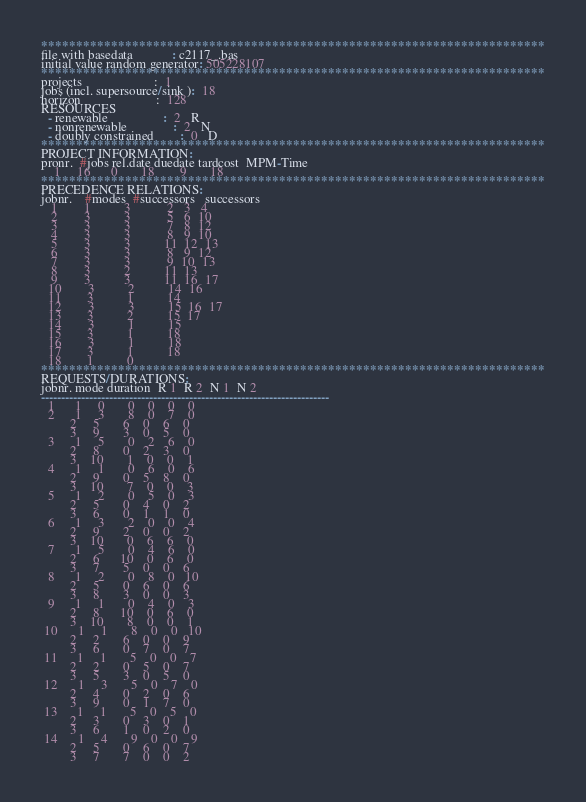<code> <loc_0><loc_0><loc_500><loc_500><_ObjectiveC_>************************************************************************
file with basedata            : c2117_.bas
initial value random generator: 505228107
************************************************************************
projects                      :  1
jobs (incl. supersource/sink ):  18
horizon                       :  128
RESOURCES
  - renewable                 :  2   R
  - nonrenewable              :  2   N
  - doubly constrained        :  0   D
************************************************************************
PROJECT INFORMATION:
pronr.  #jobs rel.date duedate tardcost  MPM-Time
    1     16      0       18        9       18
************************************************************************
PRECEDENCE RELATIONS:
jobnr.    #modes  #successors   successors
   1        1          3           2   3   4
   2        3          3           5   6  10
   3        3          3           7   8  12
   4        3          3           8   9  10
   5        3          3          11  12  13
   6        3          3           8   9  12
   7        3          3           9  10  13
   8        3          2          11  13
   9        3          3          11  16  17
  10        3          2          14  16
  11        3          1          14
  12        3          3          15  16  17
  13        3          2          15  17
  14        3          1          15
  15        3          1          18
  16        3          1          18
  17        3          1          18
  18        1          0        
************************************************************************
REQUESTS/DURATIONS:
jobnr. mode duration  R 1  R 2  N 1  N 2
------------------------------------------------------------------------
  1      1     0       0    0    0    0
  2      1     3       8    0    7    0
         2     5       6    0    6    0
         3     9       3    0    5    0
  3      1     5       0    2    6    0
         2     8       0    2    3    0
         3    10       1    0    0    1
  4      1     1       0    6    0    6
         2     9       0    5    8    0
         3    10       7    0    0    3
  5      1     2       0    5    0    3
         2     5       0    4    0    2
         3     6       0    1    1    0
  6      1     3       2    0    0    4
         2     9       2    0    0    2
         3    10       0    6    6    0
  7      1     5       0    4    6    0
         2     6      10    0    6    0
         3     7       5    0    0    6
  8      1     2       0    8    0   10
         2     5       0    6    0    6
         3     8       3    0    0    3
  9      1     1       0    4    0    3
         2     8      10    0    6    0
         3    10       8    0    0    1
 10      1     1       8    0    0   10
         2     2       6    0    0    9
         3     6       0    7    0    7
 11      1     1       5    0    0    7
         2     2       0    5    0    7
         3     5       3    0    5    0
 12      1     3       5    0    7    0
         2     4       0    2    0    6
         3     9       0    1    7    0
 13      1     1       5    0    5    0
         2     3       0    3    0    1
         3     6       1    0    2    0
 14      1     4       9    0    0    9
         2     5       0    6    0    7
         3     7       7    0    0    2</code> 